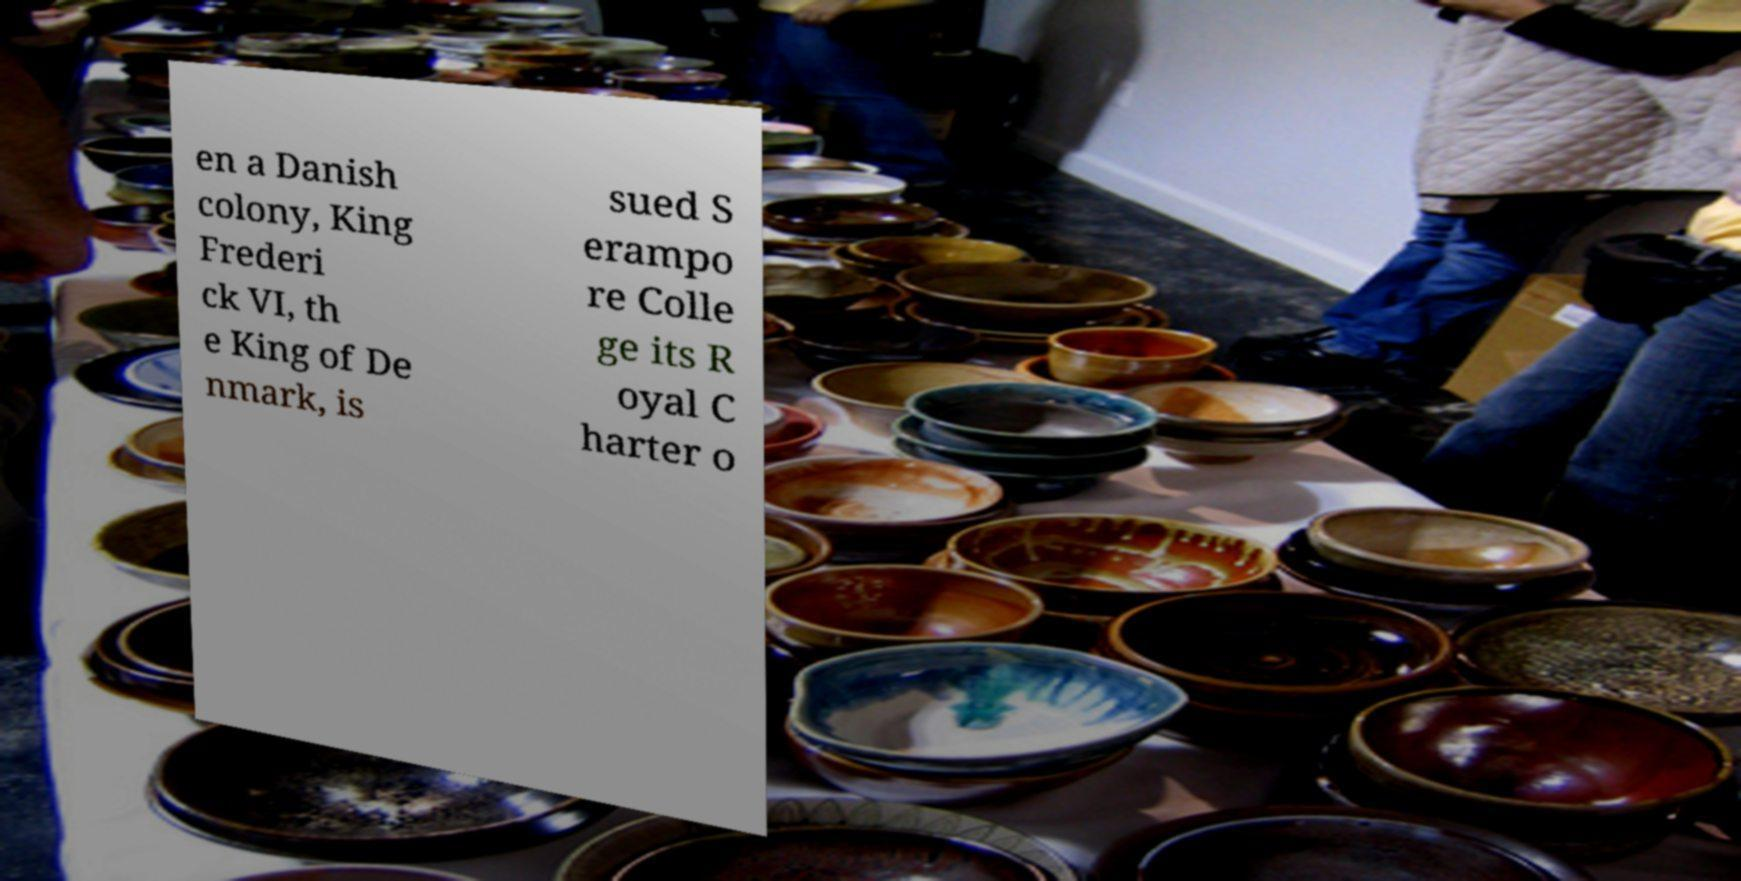Please read and relay the text visible in this image. What does it say? en a Danish colony, King Frederi ck VI, th e King of De nmark, is sued S erampo re Colle ge its R oyal C harter o 